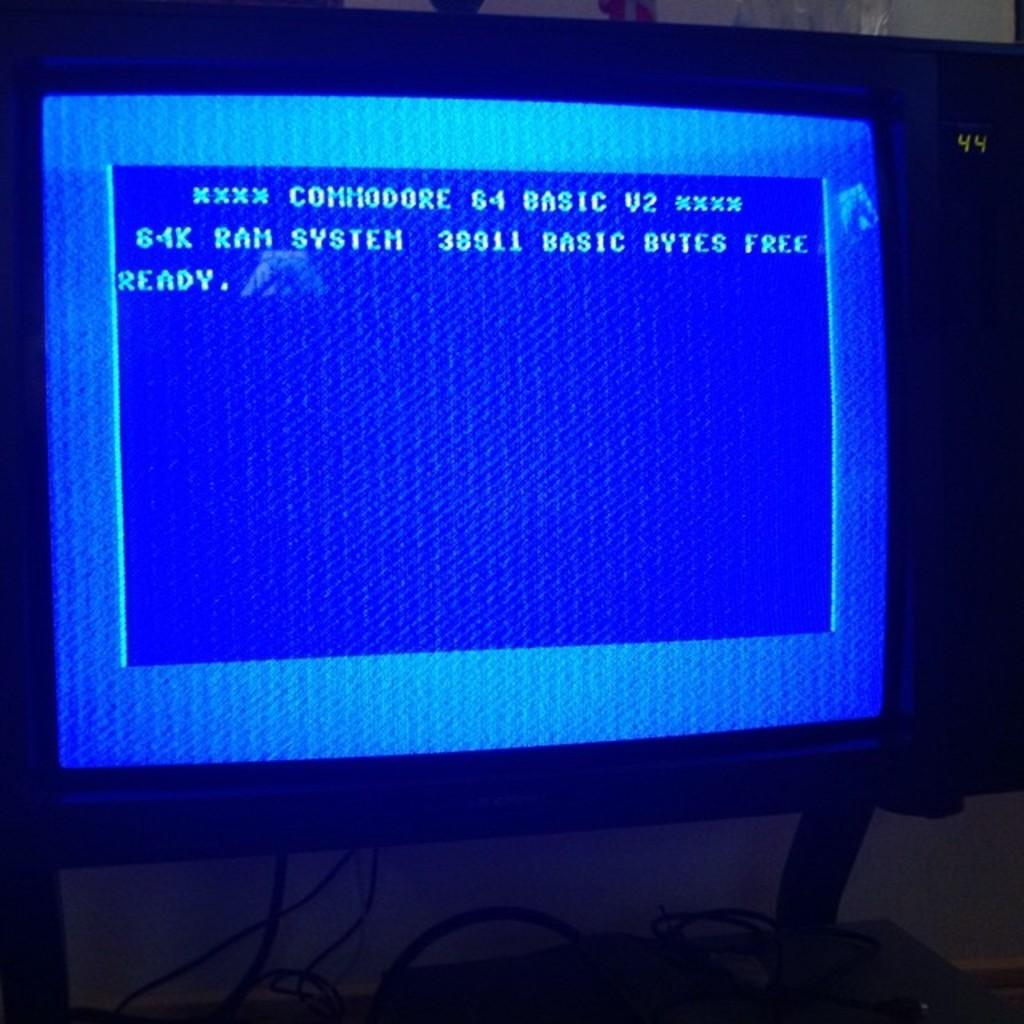<image>
Render a clear and concise summary of the photo. A blue screen shows the top line of Commodore 64 Basic V2. 